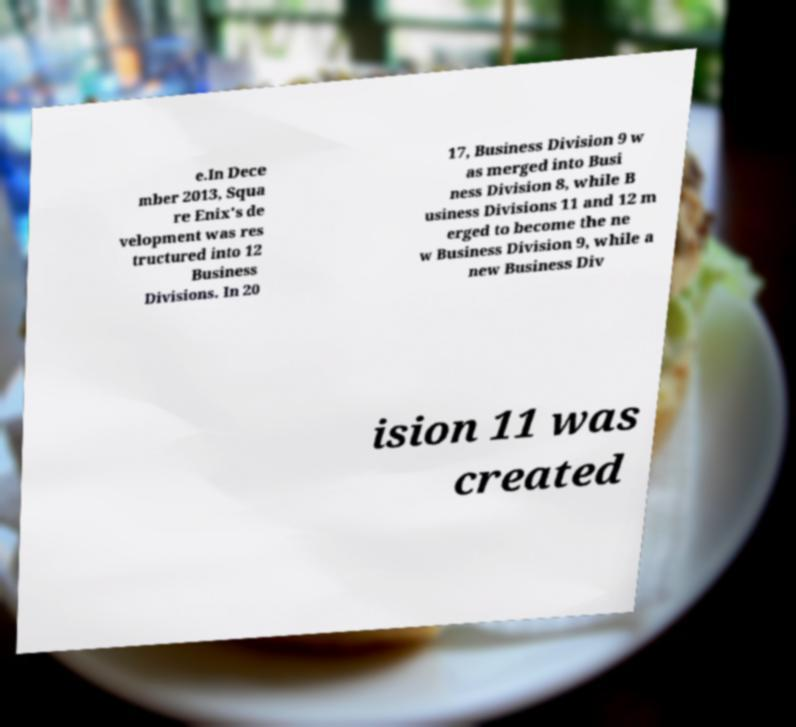Please read and relay the text visible in this image. What does it say? e.In Dece mber 2013, Squa re Enix's de velopment was res tructured into 12 Business Divisions. In 20 17, Business Division 9 w as merged into Busi ness Division 8, while B usiness Divisions 11 and 12 m erged to become the ne w Business Division 9, while a new Business Div ision 11 was created 